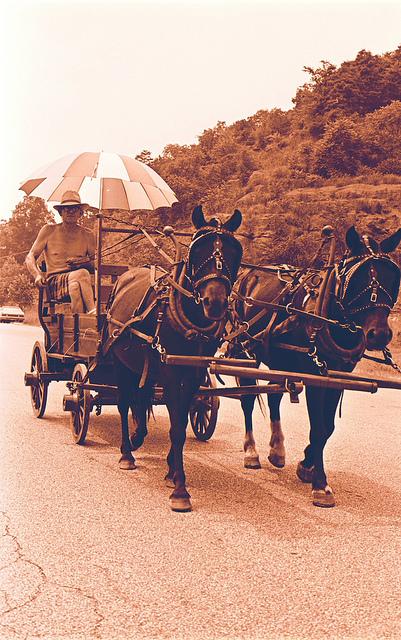How many umbrellas are there?
Short answer required. 1. Is the man wearing a shirt?
Concise answer only. No. How many horses are there?
Keep it brief. 2. 